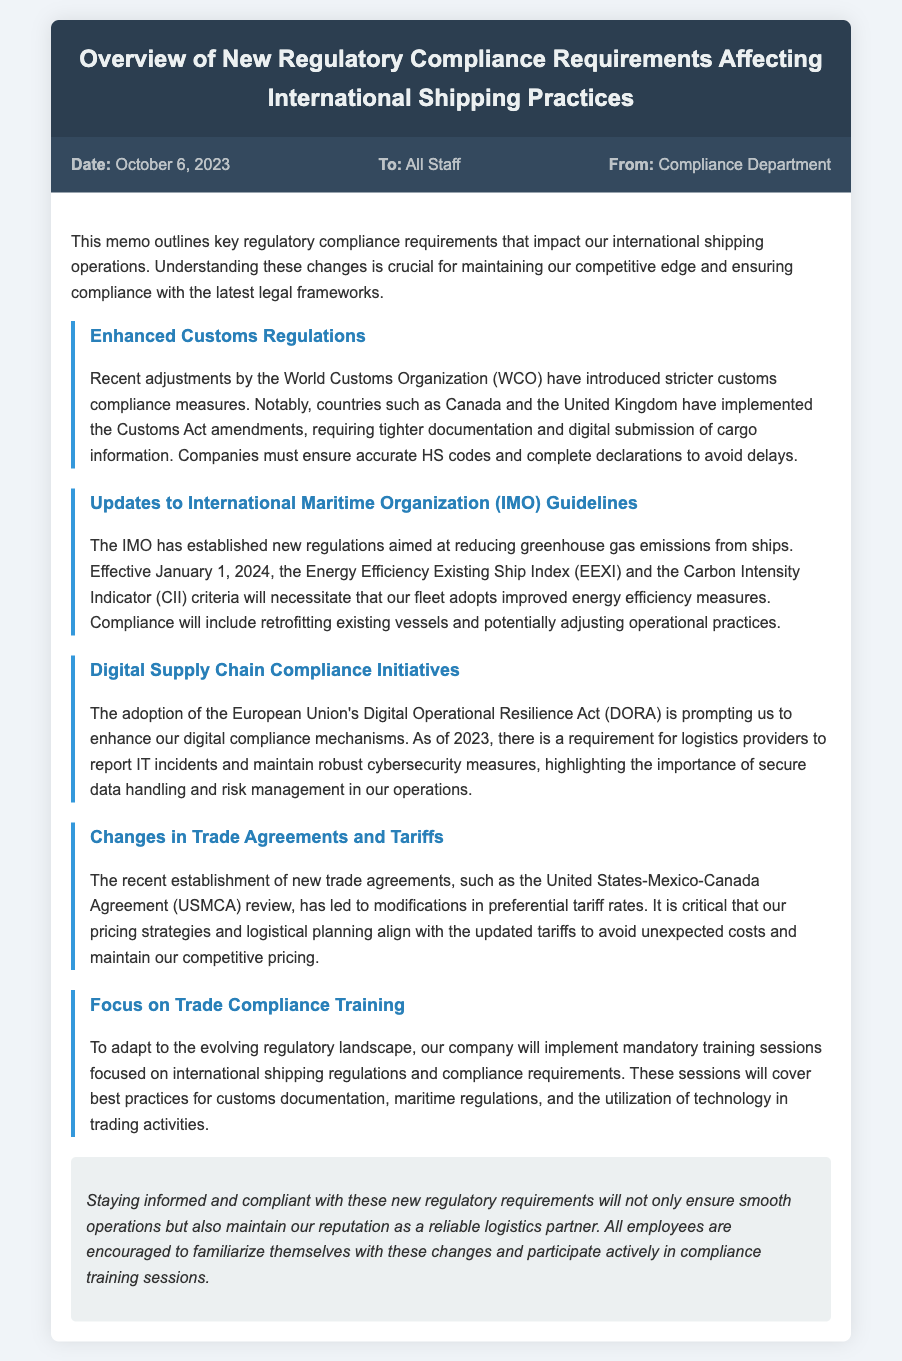What is the date of the memo? The date is specified in the memo information section.
Answer: October 6, 2023 Who is the memo addressed to? The recipient of the memo is mentioned in the document.
Answer: All Staff What is the first new requirement mentioned in the memo? The first regulatory compliance requirement discussed in the memo is highlighted in the sections.
Answer: Enhanced Customs Regulations When will the IMO guidelines take effect? The document mentions the effective date of the new IMO guidelines.
Answer: January 1, 2024 What does DORA stand for? The abbreviation for the European Union's Digital Operational Resilience Act is provided in the memo.
Answer: Digital Operational Resilience Act What is required from logistics providers under DORA? The specific requirement for logistics providers is mentioned in the document.
Answer: Report IT incidents How will compliance training be addressed? The approach to compliance training is detailed in the document.
Answer: Mandatory training sessions What does EEXI aim to improve? The intended outcome of the Energy Efficiency Existing Ship Index is stated in the memo.
Answer: Energy efficiency measures Which agreement has recently been reviewed according to the memo? The trade agreement mentioned in the memo is specified.
Answer: United States-Mexico-Canada Agreement 